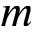<formula> <loc_0><loc_0><loc_500><loc_500>m</formula> 